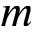<formula> <loc_0><loc_0><loc_500><loc_500>m</formula> 